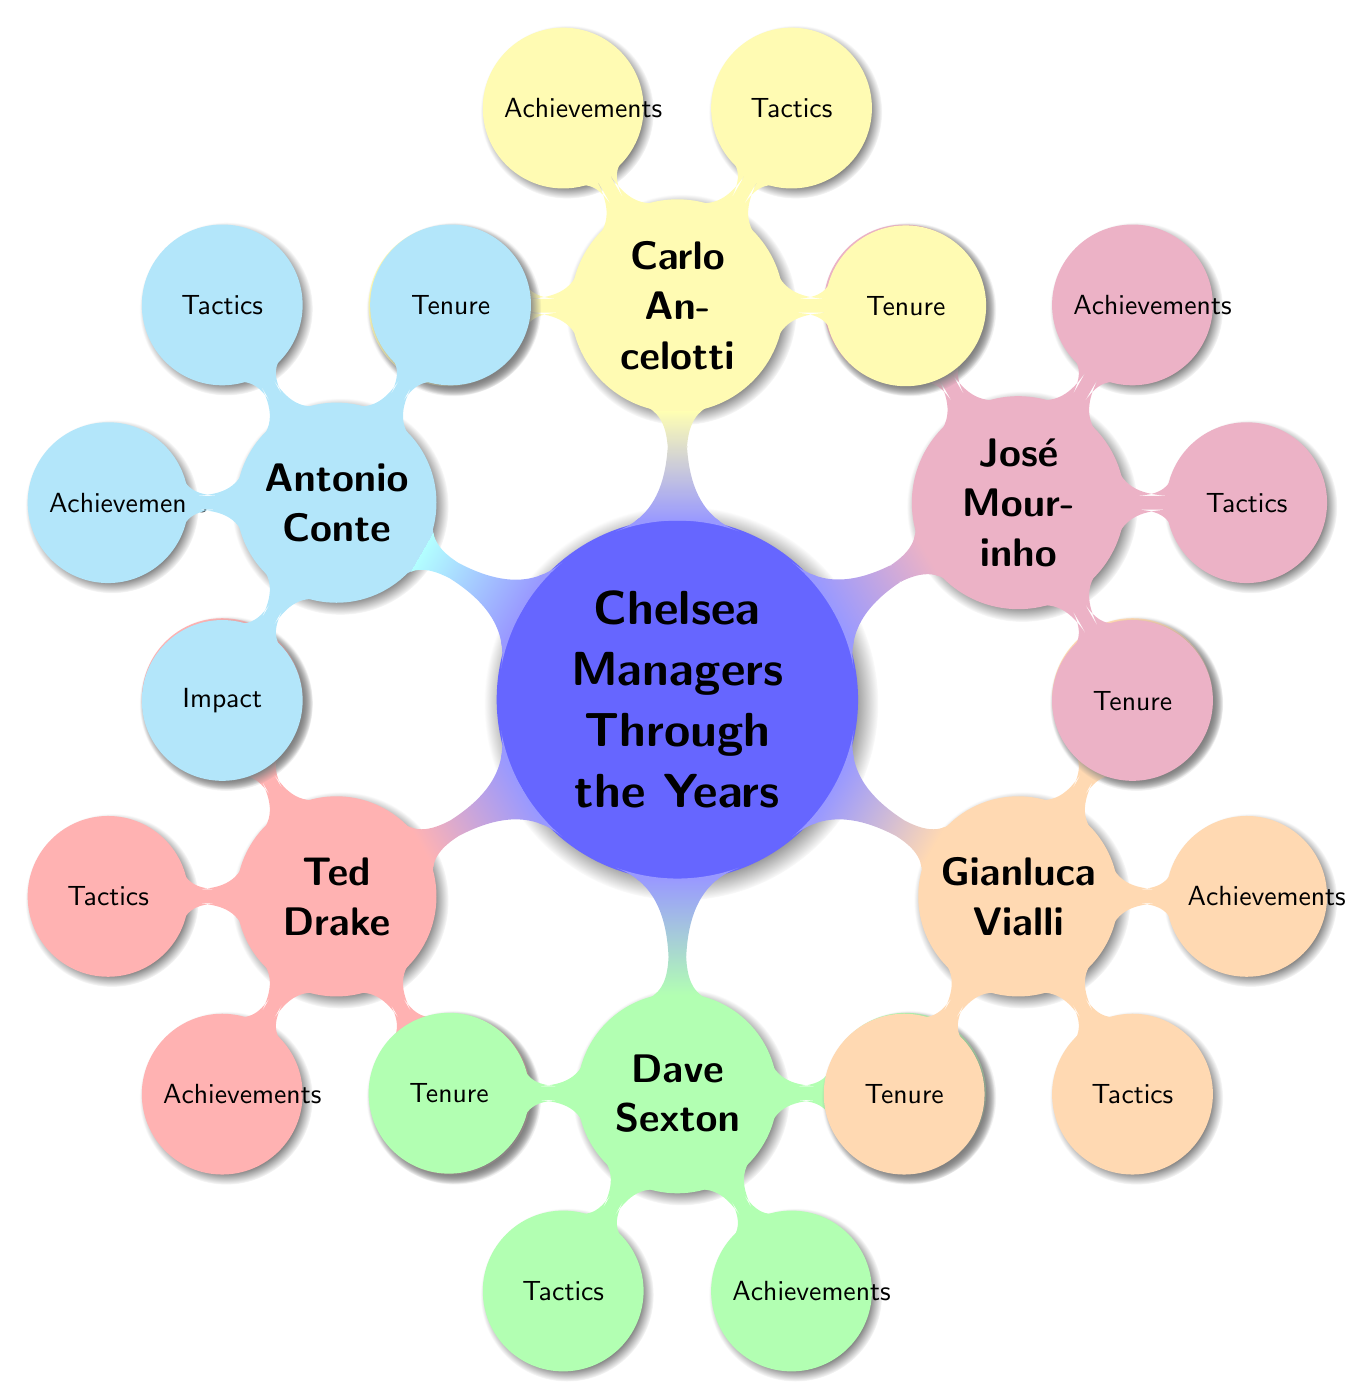What is the concept of the root node in the diagram? The root node is labeled "Chelsea Managers Through the Years," indicating the overall theme of the diagram where it explores the various managers of Chelsea FC over time.
Answer: Chelsea Managers Through the Years How many managers are listed in the diagram? By counting each child node stemming from the root concept, there are six distinct managers presented: Ted Drake, Dave Sexton, Gianluca Vialli, José Mourinho, Carlo Ancelotti, and Antonio Conte.
Answer: 6 Which manager is associated with the red color? The node colored red is associated with Ted Drake, as it is the child node under the root that follows the red color scheme in the diagram.
Answer: Ted Drake What sub-categories are shared by all managers in the diagram? Analyzing the structure, each manager has the same four sub-categories: Tenure, Tactics, Achievements, and Impact, indicating a consistent framework to discuss each manager.
Answer: Tenure, Tactics, Achievements, Impact Which manager has the highest profile in the diagram? José Mourinho is generally viewed as the highest-profile manager in the context of Chelsea's history, known for his significant success and distinctive style.
Answer: José Mourinho How many sub-categories are there for each manager? Each manager has four sub-categories branching out from their respective node, indicating a detailed look into their managerial aspects.
Answer: 4 Between which two managers is the difference in impact most notable? While the diagram does not provide specific data, reasoning based on historical context indicates that the impact of José Mourinho, known for major achievements, contrasts significantly with that of Ted Drake, who had a different influence era.
Answer: José Mourinho and Ted Drake Which colors are used to represent Carlo Ancelotti and Antonio Conte in the diagram? Carlo Ancelotti is represented by yellow, while Antonio Conte is depicted in cyan; these colors distinguish each manager visually within the diagram.
Answer: Yellow and Cyan What is the main purpose of the diagram? The main purpose of the diagram is to visually present and categorize the various Chelsea managers throughout history, focusing on their tenure, tactics, achievements, and impact on the club's legacy.
Answer: Visual Presentations of Chelsea Managers 